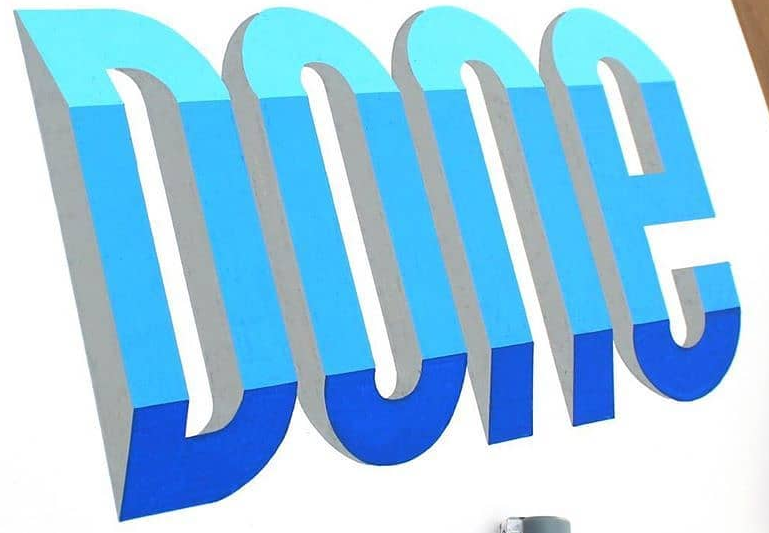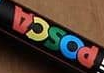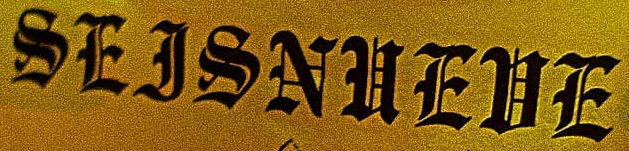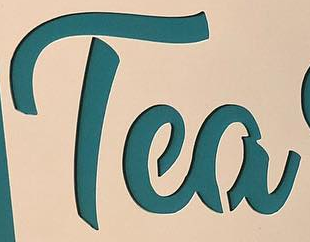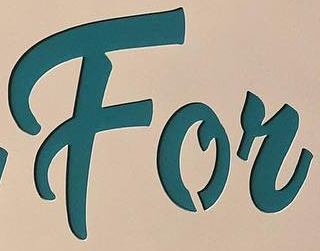What text is displayed in these images sequentially, separated by a semicolon? DOne; POSCA; SEJSNUEUE; Tea; For 